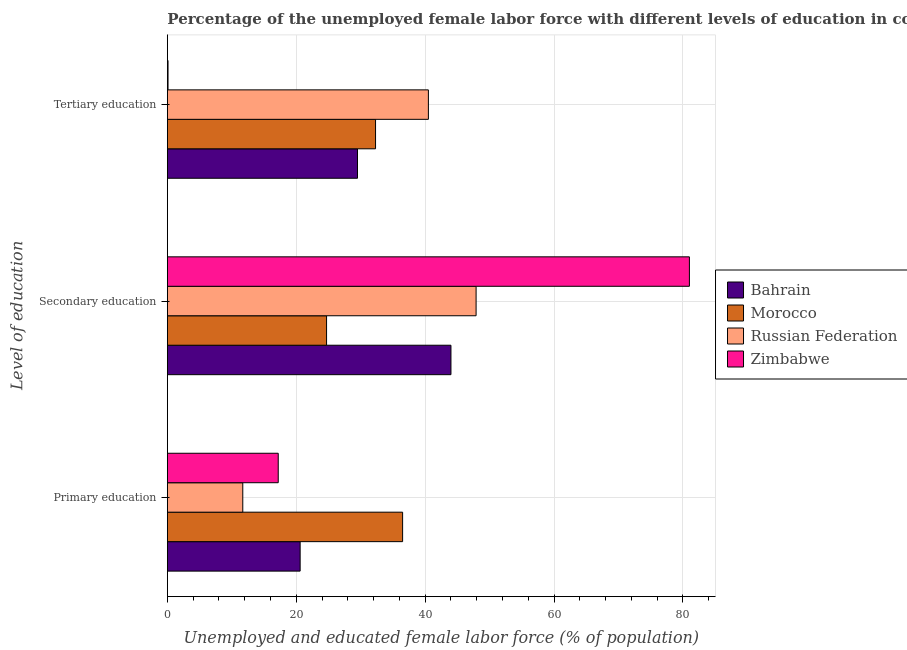How many different coloured bars are there?
Provide a succinct answer. 4. Are the number of bars per tick equal to the number of legend labels?
Ensure brevity in your answer.  Yes. Are the number of bars on each tick of the Y-axis equal?
Keep it short and to the point. Yes. How many bars are there on the 1st tick from the top?
Your answer should be very brief. 4. What is the label of the 2nd group of bars from the top?
Your answer should be compact. Secondary education. What is the percentage of female labor force who received tertiary education in Zimbabwe?
Provide a succinct answer. 0.1. Across all countries, what is the maximum percentage of female labor force who received tertiary education?
Ensure brevity in your answer.  40.5. Across all countries, what is the minimum percentage of female labor force who received primary education?
Your answer should be very brief. 11.7. In which country was the percentage of female labor force who received primary education maximum?
Your answer should be very brief. Morocco. In which country was the percentage of female labor force who received tertiary education minimum?
Offer a very short reply. Zimbabwe. What is the total percentage of female labor force who received secondary education in the graph?
Keep it short and to the point. 197.6. What is the difference between the percentage of female labor force who received primary education in Morocco and the percentage of female labor force who received secondary education in Russian Federation?
Offer a very short reply. -11.4. What is the average percentage of female labor force who received secondary education per country?
Provide a short and direct response. 49.4. What is the difference between the percentage of female labor force who received tertiary education and percentage of female labor force who received primary education in Bahrain?
Ensure brevity in your answer.  8.9. What is the ratio of the percentage of female labor force who received secondary education in Morocco to that in Zimbabwe?
Ensure brevity in your answer.  0.3. Is the difference between the percentage of female labor force who received primary education in Morocco and Russian Federation greater than the difference between the percentage of female labor force who received secondary education in Morocco and Russian Federation?
Offer a terse response. Yes. What is the difference between the highest and the second highest percentage of female labor force who received primary education?
Provide a short and direct response. 15.9. What is the difference between the highest and the lowest percentage of female labor force who received secondary education?
Keep it short and to the point. 56.3. What does the 3rd bar from the top in Tertiary education represents?
Give a very brief answer. Morocco. What does the 1st bar from the bottom in Primary education represents?
Your answer should be compact. Bahrain. Is it the case that in every country, the sum of the percentage of female labor force who received primary education and percentage of female labor force who received secondary education is greater than the percentage of female labor force who received tertiary education?
Provide a succinct answer. Yes. What is the difference between two consecutive major ticks on the X-axis?
Keep it short and to the point. 20. Are the values on the major ticks of X-axis written in scientific E-notation?
Your answer should be very brief. No. Does the graph contain any zero values?
Provide a short and direct response. No. How many legend labels are there?
Your answer should be compact. 4. What is the title of the graph?
Your response must be concise. Percentage of the unemployed female labor force with different levels of education in countries. What is the label or title of the X-axis?
Provide a short and direct response. Unemployed and educated female labor force (% of population). What is the label or title of the Y-axis?
Keep it short and to the point. Level of education. What is the Unemployed and educated female labor force (% of population) in Bahrain in Primary education?
Keep it short and to the point. 20.6. What is the Unemployed and educated female labor force (% of population) of Morocco in Primary education?
Make the answer very short. 36.5. What is the Unemployed and educated female labor force (% of population) in Russian Federation in Primary education?
Make the answer very short. 11.7. What is the Unemployed and educated female labor force (% of population) in Zimbabwe in Primary education?
Ensure brevity in your answer.  17.2. What is the Unemployed and educated female labor force (% of population) of Bahrain in Secondary education?
Offer a very short reply. 44. What is the Unemployed and educated female labor force (% of population) of Morocco in Secondary education?
Provide a succinct answer. 24.7. What is the Unemployed and educated female labor force (% of population) in Russian Federation in Secondary education?
Offer a terse response. 47.9. What is the Unemployed and educated female labor force (% of population) of Zimbabwe in Secondary education?
Give a very brief answer. 81. What is the Unemployed and educated female labor force (% of population) in Bahrain in Tertiary education?
Your answer should be compact. 29.5. What is the Unemployed and educated female labor force (% of population) in Morocco in Tertiary education?
Provide a short and direct response. 32.3. What is the Unemployed and educated female labor force (% of population) of Russian Federation in Tertiary education?
Offer a terse response. 40.5. What is the Unemployed and educated female labor force (% of population) of Zimbabwe in Tertiary education?
Provide a succinct answer. 0.1. Across all Level of education, what is the maximum Unemployed and educated female labor force (% of population) of Bahrain?
Offer a terse response. 44. Across all Level of education, what is the maximum Unemployed and educated female labor force (% of population) in Morocco?
Offer a terse response. 36.5. Across all Level of education, what is the maximum Unemployed and educated female labor force (% of population) of Russian Federation?
Make the answer very short. 47.9. Across all Level of education, what is the minimum Unemployed and educated female labor force (% of population) of Bahrain?
Provide a succinct answer. 20.6. Across all Level of education, what is the minimum Unemployed and educated female labor force (% of population) of Morocco?
Offer a terse response. 24.7. Across all Level of education, what is the minimum Unemployed and educated female labor force (% of population) in Russian Federation?
Your answer should be very brief. 11.7. Across all Level of education, what is the minimum Unemployed and educated female labor force (% of population) of Zimbabwe?
Keep it short and to the point. 0.1. What is the total Unemployed and educated female labor force (% of population) of Bahrain in the graph?
Offer a terse response. 94.1. What is the total Unemployed and educated female labor force (% of population) of Morocco in the graph?
Your response must be concise. 93.5. What is the total Unemployed and educated female labor force (% of population) in Russian Federation in the graph?
Ensure brevity in your answer.  100.1. What is the total Unemployed and educated female labor force (% of population) in Zimbabwe in the graph?
Offer a terse response. 98.3. What is the difference between the Unemployed and educated female labor force (% of population) of Bahrain in Primary education and that in Secondary education?
Provide a succinct answer. -23.4. What is the difference between the Unemployed and educated female labor force (% of population) of Morocco in Primary education and that in Secondary education?
Offer a very short reply. 11.8. What is the difference between the Unemployed and educated female labor force (% of population) of Russian Federation in Primary education and that in Secondary education?
Offer a very short reply. -36.2. What is the difference between the Unemployed and educated female labor force (% of population) in Zimbabwe in Primary education and that in Secondary education?
Provide a succinct answer. -63.8. What is the difference between the Unemployed and educated female labor force (% of population) of Bahrain in Primary education and that in Tertiary education?
Provide a succinct answer. -8.9. What is the difference between the Unemployed and educated female labor force (% of population) in Morocco in Primary education and that in Tertiary education?
Keep it short and to the point. 4.2. What is the difference between the Unemployed and educated female labor force (% of population) of Russian Federation in Primary education and that in Tertiary education?
Your response must be concise. -28.8. What is the difference between the Unemployed and educated female labor force (% of population) in Zimbabwe in Primary education and that in Tertiary education?
Give a very brief answer. 17.1. What is the difference between the Unemployed and educated female labor force (% of population) of Russian Federation in Secondary education and that in Tertiary education?
Offer a very short reply. 7.4. What is the difference between the Unemployed and educated female labor force (% of population) in Zimbabwe in Secondary education and that in Tertiary education?
Your answer should be very brief. 80.9. What is the difference between the Unemployed and educated female labor force (% of population) in Bahrain in Primary education and the Unemployed and educated female labor force (% of population) in Russian Federation in Secondary education?
Provide a succinct answer. -27.3. What is the difference between the Unemployed and educated female labor force (% of population) of Bahrain in Primary education and the Unemployed and educated female labor force (% of population) of Zimbabwe in Secondary education?
Make the answer very short. -60.4. What is the difference between the Unemployed and educated female labor force (% of population) of Morocco in Primary education and the Unemployed and educated female labor force (% of population) of Russian Federation in Secondary education?
Offer a terse response. -11.4. What is the difference between the Unemployed and educated female labor force (% of population) in Morocco in Primary education and the Unemployed and educated female labor force (% of population) in Zimbabwe in Secondary education?
Offer a very short reply. -44.5. What is the difference between the Unemployed and educated female labor force (% of population) of Russian Federation in Primary education and the Unemployed and educated female labor force (% of population) of Zimbabwe in Secondary education?
Give a very brief answer. -69.3. What is the difference between the Unemployed and educated female labor force (% of population) of Bahrain in Primary education and the Unemployed and educated female labor force (% of population) of Russian Federation in Tertiary education?
Make the answer very short. -19.9. What is the difference between the Unemployed and educated female labor force (% of population) of Bahrain in Primary education and the Unemployed and educated female labor force (% of population) of Zimbabwe in Tertiary education?
Offer a terse response. 20.5. What is the difference between the Unemployed and educated female labor force (% of population) of Morocco in Primary education and the Unemployed and educated female labor force (% of population) of Zimbabwe in Tertiary education?
Provide a short and direct response. 36.4. What is the difference between the Unemployed and educated female labor force (% of population) in Russian Federation in Primary education and the Unemployed and educated female labor force (% of population) in Zimbabwe in Tertiary education?
Your response must be concise. 11.6. What is the difference between the Unemployed and educated female labor force (% of population) in Bahrain in Secondary education and the Unemployed and educated female labor force (% of population) in Morocco in Tertiary education?
Your answer should be compact. 11.7. What is the difference between the Unemployed and educated female labor force (% of population) of Bahrain in Secondary education and the Unemployed and educated female labor force (% of population) of Zimbabwe in Tertiary education?
Keep it short and to the point. 43.9. What is the difference between the Unemployed and educated female labor force (% of population) of Morocco in Secondary education and the Unemployed and educated female labor force (% of population) of Russian Federation in Tertiary education?
Give a very brief answer. -15.8. What is the difference between the Unemployed and educated female labor force (% of population) of Morocco in Secondary education and the Unemployed and educated female labor force (% of population) of Zimbabwe in Tertiary education?
Make the answer very short. 24.6. What is the difference between the Unemployed and educated female labor force (% of population) of Russian Federation in Secondary education and the Unemployed and educated female labor force (% of population) of Zimbabwe in Tertiary education?
Provide a short and direct response. 47.8. What is the average Unemployed and educated female labor force (% of population) in Bahrain per Level of education?
Your answer should be very brief. 31.37. What is the average Unemployed and educated female labor force (% of population) in Morocco per Level of education?
Provide a succinct answer. 31.17. What is the average Unemployed and educated female labor force (% of population) in Russian Federation per Level of education?
Provide a short and direct response. 33.37. What is the average Unemployed and educated female labor force (% of population) in Zimbabwe per Level of education?
Offer a very short reply. 32.77. What is the difference between the Unemployed and educated female labor force (% of population) in Bahrain and Unemployed and educated female labor force (% of population) in Morocco in Primary education?
Your response must be concise. -15.9. What is the difference between the Unemployed and educated female labor force (% of population) of Morocco and Unemployed and educated female labor force (% of population) of Russian Federation in Primary education?
Offer a terse response. 24.8. What is the difference between the Unemployed and educated female labor force (% of population) of Morocco and Unemployed and educated female labor force (% of population) of Zimbabwe in Primary education?
Provide a succinct answer. 19.3. What is the difference between the Unemployed and educated female labor force (% of population) in Russian Federation and Unemployed and educated female labor force (% of population) in Zimbabwe in Primary education?
Provide a succinct answer. -5.5. What is the difference between the Unemployed and educated female labor force (% of population) in Bahrain and Unemployed and educated female labor force (% of population) in Morocco in Secondary education?
Offer a terse response. 19.3. What is the difference between the Unemployed and educated female labor force (% of population) of Bahrain and Unemployed and educated female labor force (% of population) of Russian Federation in Secondary education?
Give a very brief answer. -3.9. What is the difference between the Unemployed and educated female labor force (% of population) of Bahrain and Unemployed and educated female labor force (% of population) of Zimbabwe in Secondary education?
Offer a very short reply. -37. What is the difference between the Unemployed and educated female labor force (% of population) of Morocco and Unemployed and educated female labor force (% of population) of Russian Federation in Secondary education?
Your answer should be compact. -23.2. What is the difference between the Unemployed and educated female labor force (% of population) of Morocco and Unemployed and educated female labor force (% of population) of Zimbabwe in Secondary education?
Provide a short and direct response. -56.3. What is the difference between the Unemployed and educated female labor force (% of population) of Russian Federation and Unemployed and educated female labor force (% of population) of Zimbabwe in Secondary education?
Keep it short and to the point. -33.1. What is the difference between the Unemployed and educated female labor force (% of population) of Bahrain and Unemployed and educated female labor force (% of population) of Morocco in Tertiary education?
Your answer should be very brief. -2.8. What is the difference between the Unemployed and educated female labor force (% of population) in Bahrain and Unemployed and educated female labor force (% of population) in Zimbabwe in Tertiary education?
Offer a very short reply. 29.4. What is the difference between the Unemployed and educated female labor force (% of population) of Morocco and Unemployed and educated female labor force (% of population) of Russian Federation in Tertiary education?
Offer a very short reply. -8.2. What is the difference between the Unemployed and educated female labor force (% of population) of Morocco and Unemployed and educated female labor force (% of population) of Zimbabwe in Tertiary education?
Offer a terse response. 32.2. What is the difference between the Unemployed and educated female labor force (% of population) of Russian Federation and Unemployed and educated female labor force (% of population) of Zimbabwe in Tertiary education?
Your answer should be compact. 40.4. What is the ratio of the Unemployed and educated female labor force (% of population) of Bahrain in Primary education to that in Secondary education?
Ensure brevity in your answer.  0.47. What is the ratio of the Unemployed and educated female labor force (% of population) in Morocco in Primary education to that in Secondary education?
Your answer should be very brief. 1.48. What is the ratio of the Unemployed and educated female labor force (% of population) in Russian Federation in Primary education to that in Secondary education?
Your response must be concise. 0.24. What is the ratio of the Unemployed and educated female labor force (% of population) in Zimbabwe in Primary education to that in Secondary education?
Ensure brevity in your answer.  0.21. What is the ratio of the Unemployed and educated female labor force (% of population) in Bahrain in Primary education to that in Tertiary education?
Your answer should be compact. 0.7. What is the ratio of the Unemployed and educated female labor force (% of population) in Morocco in Primary education to that in Tertiary education?
Offer a very short reply. 1.13. What is the ratio of the Unemployed and educated female labor force (% of population) of Russian Federation in Primary education to that in Tertiary education?
Make the answer very short. 0.29. What is the ratio of the Unemployed and educated female labor force (% of population) in Zimbabwe in Primary education to that in Tertiary education?
Keep it short and to the point. 172. What is the ratio of the Unemployed and educated female labor force (% of population) of Bahrain in Secondary education to that in Tertiary education?
Keep it short and to the point. 1.49. What is the ratio of the Unemployed and educated female labor force (% of population) in Morocco in Secondary education to that in Tertiary education?
Provide a succinct answer. 0.76. What is the ratio of the Unemployed and educated female labor force (% of population) of Russian Federation in Secondary education to that in Tertiary education?
Your answer should be compact. 1.18. What is the ratio of the Unemployed and educated female labor force (% of population) in Zimbabwe in Secondary education to that in Tertiary education?
Ensure brevity in your answer.  810. What is the difference between the highest and the second highest Unemployed and educated female labor force (% of population) of Russian Federation?
Ensure brevity in your answer.  7.4. What is the difference between the highest and the second highest Unemployed and educated female labor force (% of population) of Zimbabwe?
Offer a terse response. 63.8. What is the difference between the highest and the lowest Unemployed and educated female labor force (% of population) in Bahrain?
Your response must be concise. 23.4. What is the difference between the highest and the lowest Unemployed and educated female labor force (% of population) in Morocco?
Make the answer very short. 11.8. What is the difference between the highest and the lowest Unemployed and educated female labor force (% of population) in Russian Federation?
Make the answer very short. 36.2. What is the difference between the highest and the lowest Unemployed and educated female labor force (% of population) in Zimbabwe?
Your response must be concise. 80.9. 